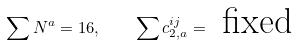<formula> <loc_0><loc_0><loc_500><loc_500>\sum N ^ { a } = 1 6 , \quad \sum c _ { 2 , a } ^ { i j } = \text { fixed}</formula> 